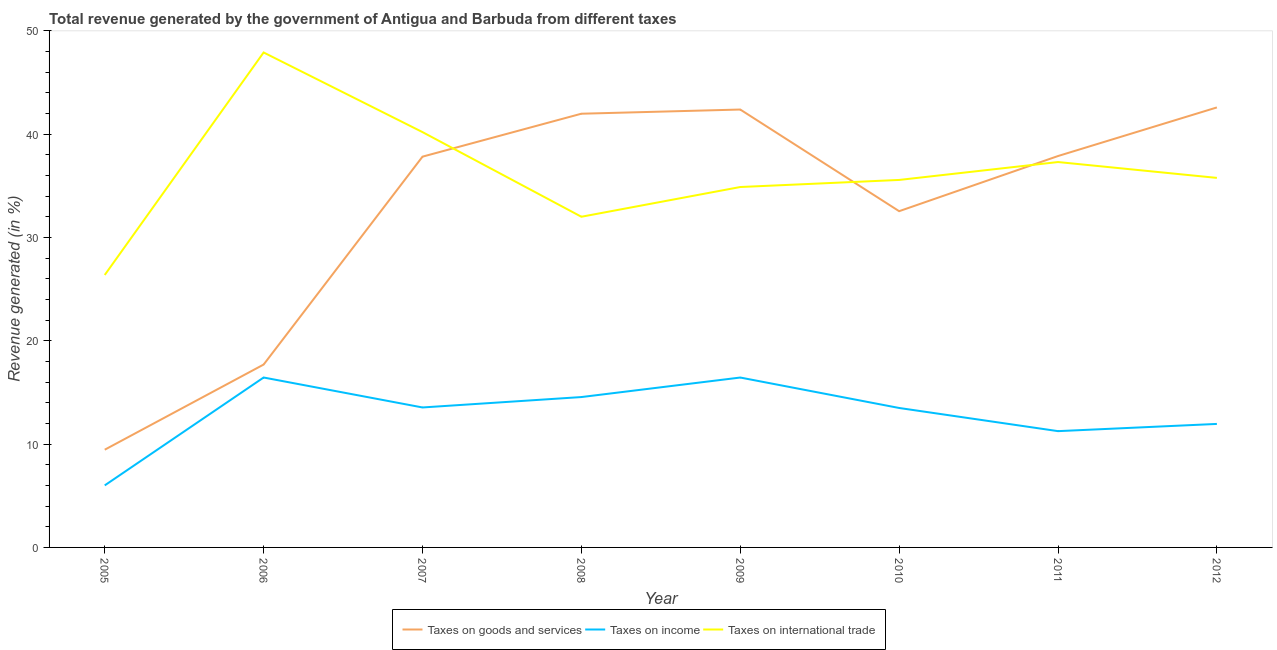Does the line corresponding to percentage of revenue generated by taxes on goods and services intersect with the line corresponding to percentage of revenue generated by taxes on income?
Offer a terse response. No. Is the number of lines equal to the number of legend labels?
Give a very brief answer. Yes. What is the percentage of revenue generated by taxes on goods and services in 2006?
Make the answer very short. 17.7. Across all years, what is the maximum percentage of revenue generated by taxes on goods and services?
Make the answer very short. 42.59. Across all years, what is the minimum percentage of revenue generated by tax on international trade?
Your answer should be very brief. 26.37. What is the total percentage of revenue generated by tax on international trade in the graph?
Give a very brief answer. 290.04. What is the difference between the percentage of revenue generated by tax on international trade in 2006 and that in 2009?
Your response must be concise. 13.02. What is the difference between the percentage of revenue generated by taxes on income in 2011 and the percentage of revenue generated by tax on international trade in 2005?
Your answer should be very brief. -15.12. What is the average percentage of revenue generated by tax on international trade per year?
Offer a very short reply. 36.26. In the year 2009, what is the difference between the percentage of revenue generated by taxes on goods and services and percentage of revenue generated by tax on international trade?
Provide a short and direct response. 7.5. What is the ratio of the percentage of revenue generated by taxes on income in 2005 to that in 2006?
Offer a terse response. 0.37. Is the difference between the percentage of revenue generated by tax on international trade in 2005 and 2006 greater than the difference between the percentage of revenue generated by taxes on income in 2005 and 2006?
Your answer should be very brief. No. What is the difference between the highest and the second highest percentage of revenue generated by taxes on goods and services?
Provide a short and direct response. 0.2. What is the difference between the highest and the lowest percentage of revenue generated by taxes on income?
Give a very brief answer. 10.44. Is the sum of the percentage of revenue generated by taxes on income in 2006 and 2011 greater than the maximum percentage of revenue generated by tax on international trade across all years?
Offer a terse response. No. Is the percentage of revenue generated by taxes on goods and services strictly less than the percentage of revenue generated by taxes on income over the years?
Make the answer very short. No. How many lines are there?
Your answer should be very brief. 3. What is the difference between two consecutive major ticks on the Y-axis?
Your answer should be compact. 10. Does the graph contain any zero values?
Offer a terse response. No. Does the graph contain grids?
Make the answer very short. No. How many legend labels are there?
Provide a short and direct response. 3. How are the legend labels stacked?
Your answer should be very brief. Horizontal. What is the title of the graph?
Your answer should be compact. Total revenue generated by the government of Antigua and Barbuda from different taxes. Does "Ireland" appear as one of the legend labels in the graph?
Keep it short and to the point. No. What is the label or title of the Y-axis?
Your answer should be compact. Revenue generated (in %). What is the Revenue generated (in %) of Taxes on goods and services in 2005?
Your response must be concise. 9.46. What is the Revenue generated (in %) in Taxes on income in 2005?
Provide a short and direct response. 6.01. What is the Revenue generated (in %) of Taxes on international trade in 2005?
Your answer should be compact. 26.37. What is the Revenue generated (in %) in Taxes on goods and services in 2006?
Your response must be concise. 17.7. What is the Revenue generated (in %) of Taxes on income in 2006?
Provide a succinct answer. 16.45. What is the Revenue generated (in %) in Taxes on international trade in 2006?
Your answer should be compact. 47.91. What is the Revenue generated (in %) in Taxes on goods and services in 2007?
Offer a terse response. 37.83. What is the Revenue generated (in %) in Taxes on income in 2007?
Provide a succinct answer. 13.55. What is the Revenue generated (in %) in Taxes on international trade in 2007?
Your answer should be compact. 40.2. What is the Revenue generated (in %) of Taxes on goods and services in 2008?
Make the answer very short. 41.98. What is the Revenue generated (in %) of Taxes on income in 2008?
Provide a succinct answer. 14.56. What is the Revenue generated (in %) in Taxes on international trade in 2008?
Make the answer very short. 32.01. What is the Revenue generated (in %) of Taxes on goods and services in 2009?
Keep it short and to the point. 42.39. What is the Revenue generated (in %) of Taxes on income in 2009?
Your response must be concise. 16.45. What is the Revenue generated (in %) of Taxes on international trade in 2009?
Provide a succinct answer. 34.89. What is the Revenue generated (in %) in Taxes on goods and services in 2010?
Your answer should be very brief. 32.55. What is the Revenue generated (in %) in Taxes on income in 2010?
Provide a succinct answer. 13.5. What is the Revenue generated (in %) of Taxes on international trade in 2010?
Ensure brevity in your answer.  35.57. What is the Revenue generated (in %) of Taxes on goods and services in 2011?
Offer a very short reply. 37.89. What is the Revenue generated (in %) in Taxes on income in 2011?
Offer a terse response. 11.26. What is the Revenue generated (in %) in Taxes on international trade in 2011?
Keep it short and to the point. 37.31. What is the Revenue generated (in %) of Taxes on goods and services in 2012?
Give a very brief answer. 42.59. What is the Revenue generated (in %) of Taxes on income in 2012?
Provide a succinct answer. 11.95. What is the Revenue generated (in %) of Taxes on international trade in 2012?
Your answer should be compact. 35.77. Across all years, what is the maximum Revenue generated (in %) of Taxes on goods and services?
Offer a very short reply. 42.59. Across all years, what is the maximum Revenue generated (in %) of Taxes on income?
Offer a very short reply. 16.45. Across all years, what is the maximum Revenue generated (in %) in Taxes on international trade?
Make the answer very short. 47.91. Across all years, what is the minimum Revenue generated (in %) of Taxes on goods and services?
Make the answer very short. 9.46. Across all years, what is the minimum Revenue generated (in %) in Taxes on income?
Your answer should be compact. 6.01. Across all years, what is the minimum Revenue generated (in %) of Taxes on international trade?
Provide a succinct answer. 26.37. What is the total Revenue generated (in %) in Taxes on goods and services in the graph?
Provide a succinct answer. 262.39. What is the total Revenue generated (in %) of Taxes on income in the graph?
Provide a succinct answer. 103.71. What is the total Revenue generated (in %) of Taxes on international trade in the graph?
Your response must be concise. 290.04. What is the difference between the Revenue generated (in %) in Taxes on goods and services in 2005 and that in 2006?
Provide a succinct answer. -8.24. What is the difference between the Revenue generated (in %) in Taxes on income in 2005 and that in 2006?
Give a very brief answer. -10.44. What is the difference between the Revenue generated (in %) in Taxes on international trade in 2005 and that in 2006?
Ensure brevity in your answer.  -21.54. What is the difference between the Revenue generated (in %) of Taxes on goods and services in 2005 and that in 2007?
Provide a short and direct response. -28.37. What is the difference between the Revenue generated (in %) in Taxes on income in 2005 and that in 2007?
Your answer should be compact. -7.54. What is the difference between the Revenue generated (in %) of Taxes on international trade in 2005 and that in 2007?
Give a very brief answer. -13.83. What is the difference between the Revenue generated (in %) in Taxes on goods and services in 2005 and that in 2008?
Provide a succinct answer. -32.52. What is the difference between the Revenue generated (in %) in Taxes on income in 2005 and that in 2008?
Provide a short and direct response. -8.55. What is the difference between the Revenue generated (in %) in Taxes on international trade in 2005 and that in 2008?
Your response must be concise. -5.64. What is the difference between the Revenue generated (in %) of Taxes on goods and services in 2005 and that in 2009?
Ensure brevity in your answer.  -32.93. What is the difference between the Revenue generated (in %) in Taxes on income in 2005 and that in 2009?
Provide a short and direct response. -10.44. What is the difference between the Revenue generated (in %) of Taxes on international trade in 2005 and that in 2009?
Keep it short and to the point. -8.51. What is the difference between the Revenue generated (in %) in Taxes on goods and services in 2005 and that in 2010?
Offer a very short reply. -23.09. What is the difference between the Revenue generated (in %) of Taxes on income in 2005 and that in 2010?
Your answer should be compact. -7.49. What is the difference between the Revenue generated (in %) in Taxes on international trade in 2005 and that in 2010?
Give a very brief answer. -9.2. What is the difference between the Revenue generated (in %) in Taxes on goods and services in 2005 and that in 2011?
Your response must be concise. -28.43. What is the difference between the Revenue generated (in %) of Taxes on income in 2005 and that in 2011?
Offer a terse response. -5.25. What is the difference between the Revenue generated (in %) of Taxes on international trade in 2005 and that in 2011?
Make the answer very short. -10.93. What is the difference between the Revenue generated (in %) in Taxes on goods and services in 2005 and that in 2012?
Your answer should be very brief. -33.13. What is the difference between the Revenue generated (in %) in Taxes on income in 2005 and that in 2012?
Your response must be concise. -5.95. What is the difference between the Revenue generated (in %) of Taxes on international trade in 2005 and that in 2012?
Provide a succinct answer. -9.4. What is the difference between the Revenue generated (in %) of Taxes on goods and services in 2006 and that in 2007?
Make the answer very short. -20.13. What is the difference between the Revenue generated (in %) in Taxes on income in 2006 and that in 2007?
Ensure brevity in your answer.  2.9. What is the difference between the Revenue generated (in %) of Taxes on international trade in 2006 and that in 2007?
Your response must be concise. 7.71. What is the difference between the Revenue generated (in %) in Taxes on goods and services in 2006 and that in 2008?
Your response must be concise. -24.28. What is the difference between the Revenue generated (in %) of Taxes on income in 2006 and that in 2008?
Keep it short and to the point. 1.89. What is the difference between the Revenue generated (in %) of Taxes on international trade in 2006 and that in 2008?
Give a very brief answer. 15.9. What is the difference between the Revenue generated (in %) in Taxes on goods and services in 2006 and that in 2009?
Offer a terse response. -24.69. What is the difference between the Revenue generated (in %) in Taxes on income in 2006 and that in 2009?
Provide a succinct answer. 0. What is the difference between the Revenue generated (in %) of Taxes on international trade in 2006 and that in 2009?
Give a very brief answer. 13.02. What is the difference between the Revenue generated (in %) of Taxes on goods and services in 2006 and that in 2010?
Provide a short and direct response. -14.85. What is the difference between the Revenue generated (in %) in Taxes on income in 2006 and that in 2010?
Ensure brevity in your answer.  2.95. What is the difference between the Revenue generated (in %) in Taxes on international trade in 2006 and that in 2010?
Offer a terse response. 12.34. What is the difference between the Revenue generated (in %) in Taxes on goods and services in 2006 and that in 2011?
Your response must be concise. -20.19. What is the difference between the Revenue generated (in %) in Taxes on income in 2006 and that in 2011?
Your answer should be very brief. 5.19. What is the difference between the Revenue generated (in %) of Taxes on international trade in 2006 and that in 2011?
Offer a very short reply. 10.61. What is the difference between the Revenue generated (in %) of Taxes on goods and services in 2006 and that in 2012?
Ensure brevity in your answer.  -24.89. What is the difference between the Revenue generated (in %) in Taxes on income in 2006 and that in 2012?
Provide a short and direct response. 4.49. What is the difference between the Revenue generated (in %) in Taxes on international trade in 2006 and that in 2012?
Provide a short and direct response. 12.14. What is the difference between the Revenue generated (in %) in Taxes on goods and services in 2007 and that in 2008?
Your answer should be compact. -4.16. What is the difference between the Revenue generated (in %) in Taxes on income in 2007 and that in 2008?
Provide a succinct answer. -1.01. What is the difference between the Revenue generated (in %) in Taxes on international trade in 2007 and that in 2008?
Give a very brief answer. 8.19. What is the difference between the Revenue generated (in %) of Taxes on goods and services in 2007 and that in 2009?
Ensure brevity in your answer.  -4.56. What is the difference between the Revenue generated (in %) in Taxes on income in 2007 and that in 2009?
Ensure brevity in your answer.  -2.9. What is the difference between the Revenue generated (in %) in Taxes on international trade in 2007 and that in 2009?
Your response must be concise. 5.32. What is the difference between the Revenue generated (in %) in Taxes on goods and services in 2007 and that in 2010?
Ensure brevity in your answer.  5.28. What is the difference between the Revenue generated (in %) in Taxes on income in 2007 and that in 2010?
Ensure brevity in your answer.  0.05. What is the difference between the Revenue generated (in %) in Taxes on international trade in 2007 and that in 2010?
Keep it short and to the point. 4.63. What is the difference between the Revenue generated (in %) of Taxes on goods and services in 2007 and that in 2011?
Offer a terse response. -0.06. What is the difference between the Revenue generated (in %) of Taxes on income in 2007 and that in 2011?
Make the answer very short. 2.29. What is the difference between the Revenue generated (in %) of Taxes on international trade in 2007 and that in 2011?
Your answer should be compact. 2.9. What is the difference between the Revenue generated (in %) in Taxes on goods and services in 2007 and that in 2012?
Provide a short and direct response. -4.76. What is the difference between the Revenue generated (in %) in Taxes on income in 2007 and that in 2012?
Provide a short and direct response. 1.59. What is the difference between the Revenue generated (in %) of Taxes on international trade in 2007 and that in 2012?
Your response must be concise. 4.43. What is the difference between the Revenue generated (in %) of Taxes on goods and services in 2008 and that in 2009?
Provide a short and direct response. -0.41. What is the difference between the Revenue generated (in %) of Taxes on income in 2008 and that in 2009?
Your response must be concise. -1.89. What is the difference between the Revenue generated (in %) in Taxes on international trade in 2008 and that in 2009?
Keep it short and to the point. -2.88. What is the difference between the Revenue generated (in %) of Taxes on goods and services in 2008 and that in 2010?
Offer a very short reply. 9.44. What is the difference between the Revenue generated (in %) in Taxes on income in 2008 and that in 2010?
Keep it short and to the point. 1.06. What is the difference between the Revenue generated (in %) of Taxes on international trade in 2008 and that in 2010?
Make the answer very short. -3.56. What is the difference between the Revenue generated (in %) in Taxes on goods and services in 2008 and that in 2011?
Provide a succinct answer. 4.1. What is the difference between the Revenue generated (in %) in Taxes on income in 2008 and that in 2011?
Give a very brief answer. 3.3. What is the difference between the Revenue generated (in %) in Taxes on international trade in 2008 and that in 2011?
Make the answer very short. -5.3. What is the difference between the Revenue generated (in %) of Taxes on goods and services in 2008 and that in 2012?
Your response must be concise. -0.61. What is the difference between the Revenue generated (in %) in Taxes on income in 2008 and that in 2012?
Give a very brief answer. 2.6. What is the difference between the Revenue generated (in %) in Taxes on international trade in 2008 and that in 2012?
Make the answer very short. -3.76. What is the difference between the Revenue generated (in %) in Taxes on goods and services in 2009 and that in 2010?
Your response must be concise. 9.84. What is the difference between the Revenue generated (in %) in Taxes on income in 2009 and that in 2010?
Offer a very short reply. 2.95. What is the difference between the Revenue generated (in %) in Taxes on international trade in 2009 and that in 2010?
Your answer should be compact. -0.69. What is the difference between the Revenue generated (in %) of Taxes on goods and services in 2009 and that in 2011?
Make the answer very short. 4.5. What is the difference between the Revenue generated (in %) in Taxes on income in 2009 and that in 2011?
Your response must be concise. 5.19. What is the difference between the Revenue generated (in %) of Taxes on international trade in 2009 and that in 2011?
Offer a terse response. -2.42. What is the difference between the Revenue generated (in %) in Taxes on goods and services in 2009 and that in 2012?
Provide a succinct answer. -0.2. What is the difference between the Revenue generated (in %) in Taxes on income in 2009 and that in 2012?
Ensure brevity in your answer.  4.49. What is the difference between the Revenue generated (in %) in Taxes on international trade in 2009 and that in 2012?
Your answer should be compact. -0.88. What is the difference between the Revenue generated (in %) in Taxes on goods and services in 2010 and that in 2011?
Provide a short and direct response. -5.34. What is the difference between the Revenue generated (in %) of Taxes on income in 2010 and that in 2011?
Ensure brevity in your answer.  2.24. What is the difference between the Revenue generated (in %) of Taxes on international trade in 2010 and that in 2011?
Offer a very short reply. -1.73. What is the difference between the Revenue generated (in %) of Taxes on goods and services in 2010 and that in 2012?
Your response must be concise. -10.04. What is the difference between the Revenue generated (in %) of Taxes on income in 2010 and that in 2012?
Provide a short and direct response. 1.54. What is the difference between the Revenue generated (in %) of Taxes on international trade in 2010 and that in 2012?
Provide a short and direct response. -0.2. What is the difference between the Revenue generated (in %) of Taxes on goods and services in 2011 and that in 2012?
Your answer should be compact. -4.7. What is the difference between the Revenue generated (in %) of Taxes on income in 2011 and that in 2012?
Your response must be concise. -0.7. What is the difference between the Revenue generated (in %) in Taxes on international trade in 2011 and that in 2012?
Ensure brevity in your answer.  1.53. What is the difference between the Revenue generated (in %) of Taxes on goods and services in 2005 and the Revenue generated (in %) of Taxes on income in 2006?
Your answer should be compact. -6.99. What is the difference between the Revenue generated (in %) of Taxes on goods and services in 2005 and the Revenue generated (in %) of Taxes on international trade in 2006?
Provide a succinct answer. -38.45. What is the difference between the Revenue generated (in %) of Taxes on income in 2005 and the Revenue generated (in %) of Taxes on international trade in 2006?
Offer a terse response. -41.91. What is the difference between the Revenue generated (in %) of Taxes on goods and services in 2005 and the Revenue generated (in %) of Taxes on income in 2007?
Your answer should be very brief. -4.09. What is the difference between the Revenue generated (in %) of Taxes on goods and services in 2005 and the Revenue generated (in %) of Taxes on international trade in 2007?
Provide a short and direct response. -30.74. What is the difference between the Revenue generated (in %) of Taxes on income in 2005 and the Revenue generated (in %) of Taxes on international trade in 2007?
Keep it short and to the point. -34.2. What is the difference between the Revenue generated (in %) in Taxes on goods and services in 2005 and the Revenue generated (in %) in Taxes on income in 2008?
Offer a terse response. -5.1. What is the difference between the Revenue generated (in %) of Taxes on goods and services in 2005 and the Revenue generated (in %) of Taxes on international trade in 2008?
Your answer should be very brief. -22.55. What is the difference between the Revenue generated (in %) of Taxes on income in 2005 and the Revenue generated (in %) of Taxes on international trade in 2008?
Your answer should be very brief. -26.01. What is the difference between the Revenue generated (in %) of Taxes on goods and services in 2005 and the Revenue generated (in %) of Taxes on income in 2009?
Provide a short and direct response. -6.99. What is the difference between the Revenue generated (in %) of Taxes on goods and services in 2005 and the Revenue generated (in %) of Taxes on international trade in 2009?
Your answer should be compact. -25.43. What is the difference between the Revenue generated (in %) of Taxes on income in 2005 and the Revenue generated (in %) of Taxes on international trade in 2009?
Make the answer very short. -28.88. What is the difference between the Revenue generated (in %) in Taxes on goods and services in 2005 and the Revenue generated (in %) in Taxes on income in 2010?
Offer a very short reply. -4.04. What is the difference between the Revenue generated (in %) in Taxes on goods and services in 2005 and the Revenue generated (in %) in Taxes on international trade in 2010?
Your response must be concise. -26.11. What is the difference between the Revenue generated (in %) of Taxes on income in 2005 and the Revenue generated (in %) of Taxes on international trade in 2010?
Your answer should be compact. -29.57. What is the difference between the Revenue generated (in %) of Taxes on goods and services in 2005 and the Revenue generated (in %) of Taxes on income in 2011?
Your response must be concise. -1.8. What is the difference between the Revenue generated (in %) in Taxes on goods and services in 2005 and the Revenue generated (in %) in Taxes on international trade in 2011?
Your answer should be compact. -27.85. What is the difference between the Revenue generated (in %) in Taxes on income in 2005 and the Revenue generated (in %) in Taxes on international trade in 2011?
Make the answer very short. -31.3. What is the difference between the Revenue generated (in %) in Taxes on goods and services in 2005 and the Revenue generated (in %) in Taxes on income in 2012?
Your answer should be very brief. -2.5. What is the difference between the Revenue generated (in %) in Taxes on goods and services in 2005 and the Revenue generated (in %) in Taxes on international trade in 2012?
Your answer should be very brief. -26.31. What is the difference between the Revenue generated (in %) of Taxes on income in 2005 and the Revenue generated (in %) of Taxes on international trade in 2012?
Give a very brief answer. -29.77. What is the difference between the Revenue generated (in %) of Taxes on goods and services in 2006 and the Revenue generated (in %) of Taxes on income in 2007?
Give a very brief answer. 4.15. What is the difference between the Revenue generated (in %) of Taxes on goods and services in 2006 and the Revenue generated (in %) of Taxes on international trade in 2007?
Make the answer very short. -22.5. What is the difference between the Revenue generated (in %) in Taxes on income in 2006 and the Revenue generated (in %) in Taxes on international trade in 2007?
Offer a very short reply. -23.76. What is the difference between the Revenue generated (in %) in Taxes on goods and services in 2006 and the Revenue generated (in %) in Taxes on income in 2008?
Make the answer very short. 3.15. What is the difference between the Revenue generated (in %) of Taxes on goods and services in 2006 and the Revenue generated (in %) of Taxes on international trade in 2008?
Give a very brief answer. -14.31. What is the difference between the Revenue generated (in %) in Taxes on income in 2006 and the Revenue generated (in %) in Taxes on international trade in 2008?
Your response must be concise. -15.56. What is the difference between the Revenue generated (in %) in Taxes on goods and services in 2006 and the Revenue generated (in %) in Taxes on income in 2009?
Offer a very short reply. 1.26. What is the difference between the Revenue generated (in %) in Taxes on goods and services in 2006 and the Revenue generated (in %) in Taxes on international trade in 2009?
Offer a terse response. -17.19. What is the difference between the Revenue generated (in %) in Taxes on income in 2006 and the Revenue generated (in %) in Taxes on international trade in 2009?
Ensure brevity in your answer.  -18.44. What is the difference between the Revenue generated (in %) in Taxes on goods and services in 2006 and the Revenue generated (in %) in Taxes on income in 2010?
Ensure brevity in your answer.  4.2. What is the difference between the Revenue generated (in %) in Taxes on goods and services in 2006 and the Revenue generated (in %) in Taxes on international trade in 2010?
Ensure brevity in your answer.  -17.87. What is the difference between the Revenue generated (in %) in Taxes on income in 2006 and the Revenue generated (in %) in Taxes on international trade in 2010?
Your answer should be compact. -19.13. What is the difference between the Revenue generated (in %) of Taxes on goods and services in 2006 and the Revenue generated (in %) of Taxes on income in 2011?
Your answer should be very brief. 6.45. What is the difference between the Revenue generated (in %) of Taxes on goods and services in 2006 and the Revenue generated (in %) of Taxes on international trade in 2011?
Offer a very short reply. -19.6. What is the difference between the Revenue generated (in %) of Taxes on income in 2006 and the Revenue generated (in %) of Taxes on international trade in 2011?
Offer a terse response. -20.86. What is the difference between the Revenue generated (in %) of Taxes on goods and services in 2006 and the Revenue generated (in %) of Taxes on income in 2012?
Provide a succinct answer. 5.75. What is the difference between the Revenue generated (in %) in Taxes on goods and services in 2006 and the Revenue generated (in %) in Taxes on international trade in 2012?
Your answer should be very brief. -18.07. What is the difference between the Revenue generated (in %) of Taxes on income in 2006 and the Revenue generated (in %) of Taxes on international trade in 2012?
Offer a terse response. -19.32. What is the difference between the Revenue generated (in %) of Taxes on goods and services in 2007 and the Revenue generated (in %) of Taxes on income in 2008?
Your response must be concise. 23.27. What is the difference between the Revenue generated (in %) of Taxes on goods and services in 2007 and the Revenue generated (in %) of Taxes on international trade in 2008?
Offer a very short reply. 5.82. What is the difference between the Revenue generated (in %) of Taxes on income in 2007 and the Revenue generated (in %) of Taxes on international trade in 2008?
Provide a short and direct response. -18.46. What is the difference between the Revenue generated (in %) in Taxes on goods and services in 2007 and the Revenue generated (in %) in Taxes on income in 2009?
Your answer should be very brief. 21.38. What is the difference between the Revenue generated (in %) of Taxes on goods and services in 2007 and the Revenue generated (in %) of Taxes on international trade in 2009?
Provide a short and direct response. 2.94. What is the difference between the Revenue generated (in %) of Taxes on income in 2007 and the Revenue generated (in %) of Taxes on international trade in 2009?
Your response must be concise. -21.34. What is the difference between the Revenue generated (in %) of Taxes on goods and services in 2007 and the Revenue generated (in %) of Taxes on income in 2010?
Provide a short and direct response. 24.33. What is the difference between the Revenue generated (in %) in Taxes on goods and services in 2007 and the Revenue generated (in %) in Taxes on international trade in 2010?
Offer a very short reply. 2.25. What is the difference between the Revenue generated (in %) in Taxes on income in 2007 and the Revenue generated (in %) in Taxes on international trade in 2010?
Make the answer very short. -22.02. What is the difference between the Revenue generated (in %) of Taxes on goods and services in 2007 and the Revenue generated (in %) of Taxes on income in 2011?
Provide a short and direct response. 26.57. What is the difference between the Revenue generated (in %) of Taxes on goods and services in 2007 and the Revenue generated (in %) of Taxes on international trade in 2011?
Your response must be concise. 0.52. What is the difference between the Revenue generated (in %) of Taxes on income in 2007 and the Revenue generated (in %) of Taxes on international trade in 2011?
Offer a terse response. -23.76. What is the difference between the Revenue generated (in %) of Taxes on goods and services in 2007 and the Revenue generated (in %) of Taxes on income in 2012?
Keep it short and to the point. 25.87. What is the difference between the Revenue generated (in %) of Taxes on goods and services in 2007 and the Revenue generated (in %) of Taxes on international trade in 2012?
Your answer should be very brief. 2.06. What is the difference between the Revenue generated (in %) in Taxes on income in 2007 and the Revenue generated (in %) in Taxes on international trade in 2012?
Your answer should be very brief. -22.22. What is the difference between the Revenue generated (in %) in Taxes on goods and services in 2008 and the Revenue generated (in %) in Taxes on income in 2009?
Provide a succinct answer. 25.54. What is the difference between the Revenue generated (in %) of Taxes on goods and services in 2008 and the Revenue generated (in %) of Taxes on international trade in 2009?
Offer a very short reply. 7.1. What is the difference between the Revenue generated (in %) in Taxes on income in 2008 and the Revenue generated (in %) in Taxes on international trade in 2009?
Your answer should be compact. -20.33. What is the difference between the Revenue generated (in %) of Taxes on goods and services in 2008 and the Revenue generated (in %) of Taxes on income in 2010?
Give a very brief answer. 28.49. What is the difference between the Revenue generated (in %) of Taxes on goods and services in 2008 and the Revenue generated (in %) of Taxes on international trade in 2010?
Your response must be concise. 6.41. What is the difference between the Revenue generated (in %) of Taxes on income in 2008 and the Revenue generated (in %) of Taxes on international trade in 2010?
Give a very brief answer. -21.02. What is the difference between the Revenue generated (in %) of Taxes on goods and services in 2008 and the Revenue generated (in %) of Taxes on income in 2011?
Make the answer very short. 30.73. What is the difference between the Revenue generated (in %) in Taxes on goods and services in 2008 and the Revenue generated (in %) in Taxes on international trade in 2011?
Offer a terse response. 4.68. What is the difference between the Revenue generated (in %) in Taxes on income in 2008 and the Revenue generated (in %) in Taxes on international trade in 2011?
Keep it short and to the point. -22.75. What is the difference between the Revenue generated (in %) in Taxes on goods and services in 2008 and the Revenue generated (in %) in Taxes on income in 2012?
Provide a succinct answer. 30.03. What is the difference between the Revenue generated (in %) of Taxes on goods and services in 2008 and the Revenue generated (in %) of Taxes on international trade in 2012?
Give a very brief answer. 6.21. What is the difference between the Revenue generated (in %) of Taxes on income in 2008 and the Revenue generated (in %) of Taxes on international trade in 2012?
Give a very brief answer. -21.22. What is the difference between the Revenue generated (in %) in Taxes on goods and services in 2009 and the Revenue generated (in %) in Taxes on income in 2010?
Your response must be concise. 28.89. What is the difference between the Revenue generated (in %) in Taxes on goods and services in 2009 and the Revenue generated (in %) in Taxes on international trade in 2010?
Make the answer very short. 6.82. What is the difference between the Revenue generated (in %) of Taxes on income in 2009 and the Revenue generated (in %) of Taxes on international trade in 2010?
Offer a very short reply. -19.13. What is the difference between the Revenue generated (in %) in Taxes on goods and services in 2009 and the Revenue generated (in %) in Taxes on income in 2011?
Provide a succinct answer. 31.13. What is the difference between the Revenue generated (in %) of Taxes on goods and services in 2009 and the Revenue generated (in %) of Taxes on international trade in 2011?
Make the answer very short. 5.08. What is the difference between the Revenue generated (in %) in Taxes on income in 2009 and the Revenue generated (in %) in Taxes on international trade in 2011?
Provide a short and direct response. -20.86. What is the difference between the Revenue generated (in %) of Taxes on goods and services in 2009 and the Revenue generated (in %) of Taxes on income in 2012?
Make the answer very short. 30.43. What is the difference between the Revenue generated (in %) in Taxes on goods and services in 2009 and the Revenue generated (in %) in Taxes on international trade in 2012?
Make the answer very short. 6.62. What is the difference between the Revenue generated (in %) in Taxes on income in 2009 and the Revenue generated (in %) in Taxes on international trade in 2012?
Give a very brief answer. -19.33. What is the difference between the Revenue generated (in %) of Taxes on goods and services in 2010 and the Revenue generated (in %) of Taxes on income in 2011?
Your answer should be very brief. 21.29. What is the difference between the Revenue generated (in %) in Taxes on goods and services in 2010 and the Revenue generated (in %) in Taxes on international trade in 2011?
Your answer should be very brief. -4.76. What is the difference between the Revenue generated (in %) of Taxes on income in 2010 and the Revenue generated (in %) of Taxes on international trade in 2011?
Offer a very short reply. -23.81. What is the difference between the Revenue generated (in %) of Taxes on goods and services in 2010 and the Revenue generated (in %) of Taxes on income in 2012?
Offer a terse response. 20.59. What is the difference between the Revenue generated (in %) of Taxes on goods and services in 2010 and the Revenue generated (in %) of Taxes on international trade in 2012?
Provide a succinct answer. -3.22. What is the difference between the Revenue generated (in %) of Taxes on income in 2010 and the Revenue generated (in %) of Taxes on international trade in 2012?
Offer a very short reply. -22.27. What is the difference between the Revenue generated (in %) in Taxes on goods and services in 2011 and the Revenue generated (in %) in Taxes on income in 2012?
Your answer should be compact. 25.93. What is the difference between the Revenue generated (in %) in Taxes on goods and services in 2011 and the Revenue generated (in %) in Taxes on international trade in 2012?
Keep it short and to the point. 2.12. What is the difference between the Revenue generated (in %) in Taxes on income in 2011 and the Revenue generated (in %) in Taxes on international trade in 2012?
Offer a terse response. -24.52. What is the average Revenue generated (in %) in Taxes on goods and services per year?
Your response must be concise. 32.8. What is the average Revenue generated (in %) of Taxes on income per year?
Your answer should be very brief. 12.96. What is the average Revenue generated (in %) in Taxes on international trade per year?
Provide a succinct answer. 36.26. In the year 2005, what is the difference between the Revenue generated (in %) in Taxes on goods and services and Revenue generated (in %) in Taxes on income?
Provide a short and direct response. 3.45. In the year 2005, what is the difference between the Revenue generated (in %) in Taxes on goods and services and Revenue generated (in %) in Taxes on international trade?
Offer a terse response. -16.91. In the year 2005, what is the difference between the Revenue generated (in %) in Taxes on income and Revenue generated (in %) in Taxes on international trade?
Offer a terse response. -20.37. In the year 2006, what is the difference between the Revenue generated (in %) of Taxes on goods and services and Revenue generated (in %) of Taxes on income?
Offer a very short reply. 1.25. In the year 2006, what is the difference between the Revenue generated (in %) in Taxes on goods and services and Revenue generated (in %) in Taxes on international trade?
Keep it short and to the point. -30.21. In the year 2006, what is the difference between the Revenue generated (in %) in Taxes on income and Revenue generated (in %) in Taxes on international trade?
Keep it short and to the point. -31.46. In the year 2007, what is the difference between the Revenue generated (in %) in Taxes on goods and services and Revenue generated (in %) in Taxes on income?
Provide a succinct answer. 24.28. In the year 2007, what is the difference between the Revenue generated (in %) of Taxes on goods and services and Revenue generated (in %) of Taxes on international trade?
Your answer should be compact. -2.38. In the year 2007, what is the difference between the Revenue generated (in %) of Taxes on income and Revenue generated (in %) of Taxes on international trade?
Provide a short and direct response. -26.66. In the year 2008, what is the difference between the Revenue generated (in %) in Taxes on goods and services and Revenue generated (in %) in Taxes on income?
Your answer should be very brief. 27.43. In the year 2008, what is the difference between the Revenue generated (in %) in Taxes on goods and services and Revenue generated (in %) in Taxes on international trade?
Make the answer very short. 9.97. In the year 2008, what is the difference between the Revenue generated (in %) in Taxes on income and Revenue generated (in %) in Taxes on international trade?
Offer a terse response. -17.45. In the year 2009, what is the difference between the Revenue generated (in %) in Taxes on goods and services and Revenue generated (in %) in Taxes on income?
Ensure brevity in your answer.  25.94. In the year 2009, what is the difference between the Revenue generated (in %) in Taxes on goods and services and Revenue generated (in %) in Taxes on international trade?
Offer a very short reply. 7.5. In the year 2009, what is the difference between the Revenue generated (in %) in Taxes on income and Revenue generated (in %) in Taxes on international trade?
Your response must be concise. -18.44. In the year 2010, what is the difference between the Revenue generated (in %) in Taxes on goods and services and Revenue generated (in %) in Taxes on income?
Your answer should be compact. 19.05. In the year 2010, what is the difference between the Revenue generated (in %) of Taxes on goods and services and Revenue generated (in %) of Taxes on international trade?
Provide a succinct answer. -3.02. In the year 2010, what is the difference between the Revenue generated (in %) in Taxes on income and Revenue generated (in %) in Taxes on international trade?
Keep it short and to the point. -22.07. In the year 2011, what is the difference between the Revenue generated (in %) in Taxes on goods and services and Revenue generated (in %) in Taxes on income?
Provide a succinct answer. 26.63. In the year 2011, what is the difference between the Revenue generated (in %) of Taxes on goods and services and Revenue generated (in %) of Taxes on international trade?
Make the answer very short. 0.58. In the year 2011, what is the difference between the Revenue generated (in %) of Taxes on income and Revenue generated (in %) of Taxes on international trade?
Your response must be concise. -26.05. In the year 2012, what is the difference between the Revenue generated (in %) of Taxes on goods and services and Revenue generated (in %) of Taxes on income?
Make the answer very short. 30.64. In the year 2012, what is the difference between the Revenue generated (in %) in Taxes on goods and services and Revenue generated (in %) in Taxes on international trade?
Your answer should be compact. 6.82. In the year 2012, what is the difference between the Revenue generated (in %) in Taxes on income and Revenue generated (in %) in Taxes on international trade?
Offer a terse response. -23.82. What is the ratio of the Revenue generated (in %) in Taxes on goods and services in 2005 to that in 2006?
Offer a very short reply. 0.53. What is the ratio of the Revenue generated (in %) in Taxes on income in 2005 to that in 2006?
Make the answer very short. 0.37. What is the ratio of the Revenue generated (in %) of Taxes on international trade in 2005 to that in 2006?
Offer a very short reply. 0.55. What is the ratio of the Revenue generated (in %) in Taxes on goods and services in 2005 to that in 2007?
Keep it short and to the point. 0.25. What is the ratio of the Revenue generated (in %) of Taxes on income in 2005 to that in 2007?
Your response must be concise. 0.44. What is the ratio of the Revenue generated (in %) of Taxes on international trade in 2005 to that in 2007?
Your answer should be very brief. 0.66. What is the ratio of the Revenue generated (in %) of Taxes on goods and services in 2005 to that in 2008?
Offer a very short reply. 0.23. What is the ratio of the Revenue generated (in %) of Taxes on income in 2005 to that in 2008?
Your answer should be compact. 0.41. What is the ratio of the Revenue generated (in %) in Taxes on international trade in 2005 to that in 2008?
Your answer should be very brief. 0.82. What is the ratio of the Revenue generated (in %) in Taxes on goods and services in 2005 to that in 2009?
Keep it short and to the point. 0.22. What is the ratio of the Revenue generated (in %) of Taxes on income in 2005 to that in 2009?
Keep it short and to the point. 0.37. What is the ratio of the Revenue generated (in %) in Taxes on international trade in 2005 to that in 2009?
Your answer should be compact. 0.76. What is the ratio of the Revenue generated (in %) of Taxes on goods and services in 2005 to that in 2010?
Offer a terse response. 0.29. What is the ratio of the Revenue generated (in %) in Taxes on income in 2005 to that in 2010?
Keep it short and to the point. 0.44. What is the ratio of the Revenue generated (in %) in Taxes on international trade in 2005 to that in 2010?
Your response must be concise. 0.74. What is the ratio of the Revenue generated (in %) in Taxes on goods and services in 2005 to that in 2011?
Your answer should be compact. 0.25. What is the ratio of the Revenue generated (in %) in Taxes on income in 2005 to that in 2011?
Keep it short and to the point. 0.53. What is the ratio of the Revenue generated (in %) in Taxes on international trade in 2005 to that in 2011?
Make the answer very short. 0.71. What is the ratio of the Revenue generated (in %) of Taxes on goods and services in 2005 to that in 2012?
Your answer should be very brief. 0.22. What is the ratio of the Revenue generated (in %) in Taxes on income in 2005 to that in 2012?
Ensure brevity in your answer.  0.5. What is the ratio of the Revenue generated (in %) in Taxes on international trade in 2005 to that in 2012?
Give a very brief answer. 0.74. What is the ratio of the Revenue generated (in %) in Taxes on goods and services in 2006 to that in 2007?
Your answer should be compact. 0.47. What is the ratio of the Revenue generated (in %) in Taxes on income in 2006 to that in 2007?
Your answer should be very brief. 1.21. What is the ratio of the Revenue generated (in %) of Taxes on international trade in 2006 to that in 2007?
Your answer should be very brief. 1.19. What is the ratio of the Revenue generated (in %) of Taxes on goods and services in 2006 to that in 2008?
Keep it short and to the point. 0.42. What is the ratio of the Revenue generated (in %) in Taxes on income in 2006 to that in 2008?
Offer a terse response. 1.13. What is the ratio of the Revenue generated (in %) of Taxes on international trade in 2006 to that in 2008?
Your answer should be compact. 1.5. What is the ratio of the Revenue generated (in %) of Taxes on goods and services in 2006 to that in 2009?
Your response must be concise. 0.42. What is the ratio of the Revenue generated (in %) in Taxes on international trade in 2006 to that in 2009?
Make the answer very short. 1.37. What is the ratio of the Revenue generated (in %) of Taxes on goods and services in 2006 to that in 2010?
Your response must be concise. 0.54. What is the ratio of the Revenue generated (in %) of Taxes on income in 2006 to that in 2010?
Offer a very short reply. 1.22. What is the ratio of the Revenue generated (in %) of Taxes on international trade in 2006 to that in 2010?
Offer a very short reply. 1.35. What is the ratio of the Revenue generated (in %) in Taxes on goods and services in 2006 to that in 2011?
Your answer should be very brief. 0.47. What is the ratio of the Revenue generated (in %) of Taxes on income in 2006 to that in 2011?
Your answer should be compact. 1.46. What is the ratio of the Revenue generated (in %) in Taxes on international trade in 2006 to that in 2011?
Ensure brevity in your answer.  1.28. What is the ratio of the Revenue generated (in %) in Taxes on goods and services in 2006 to that in 2012?
Ensure brevity in your answer.  0.42. What is the ratio of the Revenue generated (in %) in Taxes on income in 2006 to that in 2012?
Your response must be concise. 1.38. What is the ratio of the Revenue generated (in %) in Taxes on international trade in 2006 to that in 2012?
Your answer should be compact. 1.34. What is the ratio of the Revenue generated (in %) of Taxes on goods and services in 2007 to that in 2008?
Offer a terse response. 0.9. What is the ratio of the Revenue generated (in %) in Taxes on income in 2007 to that in 2008?
Ensure brevity in your answer.  0.93. What is the ratio of the Revenue generated (in %) in Taxes on international trade in 2007 to that in 2008?
Your response must be concise. 1.26. What is the ratio of the Revenue generated (in %) of Taxes on goods and services in 2007 to that in 2009?
Provide a succinct answer. 0.89. What is the ratio of the Revenue generated (in %) in Taxes on income in 2007 to that in 2009?
Give a very brief answer. 0.82. What is the ratio of the Revenue generated (in %) in Taxes on international trade in 2007 to that in 2009?
Your answer should be compact. 1.15. What is the ratio of the Revenue generated (in %) of Taxes on goods and services in 2007 to that in 2010?
Give a very brief answer. 1.16. What is the ratio of the Revenue generated (in %) in Taxes on income in 2007 to that in 2010?
Provide a short and direct response. 1. What is the ratio of the Revenue generated (in %) of Taxes on international trade in 2007 to that in 2010?
Ensure brevity in your answer.  1.13. What is the ratio of the Revenue generated (in %) of Taxes on goods and services in 2007 to that in 2011?
Make the answer very short. 1. What is the ratio of the Revenue generated (in %) of Taxes on income in 2007 to that in 2011?
Your answer should be very brief. 1.2. What is the ratio of the Revenue generated (in %) of Taxes on international trade in 2007 to that in 2011?
Offer a very short reply. 1.08. What is the ratio of the Revenue generated (in %) in Taxes on goods and services in 2007 to that in 2012?
Offer a terse response. 0.89. What is the ratio of the Revenue generated (in %) of Taxes on income in 2007 to that in 2012?
Provide a succinct answer. 1.13. What is the ratio of the Revenue generated (in %) of Taxes on international trade in 2007 to that in 2012?
Give a very brief answer. 1.12. What is the ratio of the Revenue generated (in %) in Taxes on income in 2008 to that in 2009?
Keep it short and to the point. 0.89. What is the ratio of the Revenue generated (in %) in Taxes on international trade in 2008 to that in 2009?
Offer a very short reply. 0.92. What is the ratio of the Revenue generated (in %) of Taxes on goods and services in 2008 to that in 2010?
Offer a very short reply. 1.29. What is the ratio of the Revenue generated (in %) of Taxes on income in 2008 to that in 2010?
Your response must be concise. 1.08. What is the ratio of the Revenue generated (in %) of Taxes on international trade in 2008 to that in 2010?
Ensure brevity in your answer.  0.9. What is the ratio of the Revenue generated (in %) of Taxes on goods and services in 2008 to that in 2011?
Your response must be concise. 1.11. What is the ratio of the Revenue generated (in %) of Taxes on income in 2008 to that in 2011?
Give a very brief answer. 1.29. What is the ratio of the Revenue generated (in %) in Taxes on international trade in 2008 to that in 2011?
Ensure brevity in your answer.  0.86. What is the ratio of the Revenue generated (in %) of Taxes on goods and services in 2008 to that in 2012?
Offer a terse response. 0.99. What is the ratio of the Revenue generated (in %) of Taxes on income in 2008 to that in 2012?
Your answer should be compact. 1.22. What is the ratio of the Revenue generated (in %) in Taxes on international trade in 2008 to that in 2012?
Make the answer very short. 0.89. What is the ratio of the Revenue generated (in %) in Taxes on goods and services in 2009 to that in 2010?
Provide a short and direct response. 1.3. What is the ratio of the Revenue generated (in %) of Taxes on income in 2009 to that in 2010?
Give a very brief answer. 1.22. What is the ratio of the Revenue generated (in %) in Taxes on international trade in 2009 to that in 2010?
Your response must be concise. 0.98. What is the ratio of the Revenue generated (in %) in Taxes on goods and services in 2009 to that in 2011?
Make the answer very short. 1.12. What is the ratio of the Revenue generated (in %) in Taxes on income in 2009 to that in 2011?
Your answer should be very brief. 1.46. What is the ratio of the Revenue generated (in %) in Taxes on international trade in 2009 to that in 2011?
Offer a very short reply. 0.94. What is the ratio of the Revenue generated (in %) in Taxes on goods and services in 2009 to that in 2012?
Provide a short and direct response. 1. What is the ratio of the Revenue generated (in %) of Taxes on income in 2009 to that in 2012?
Your answer should be compact. 1.38. What is the ratio of the Revenue generated (in %) of Taxes on international trade in 2009 to that in 2012?
Offer a very short reply. 0.98. What is the ratio of the Revenue generated (in %) in Taxes on goods and services in 2010 to that in 2011?
Ensure brevity in your answer.  0.86. What is the ratio of the Revenue generated (in %) in Taxes on income in 2010 to that in 2011?
Offer a terse response. 1.2. What is the ratio of the Revenue generated (in %) in Taxes on international trade in 2010 to that in 2011?
Make the answer very short. 0.95. What is the ratio of the Revenue generated (in %) in Taxes on goods and services in 2010 to that in 2012?
Your response must be concise. 0.76. What is the ratio of the Revenue generated (in %) in Taxes on income in 2010 to that in 2012?
Keep it short and to the point. 1.13. What is the ratio of the Revenue generated (in %) of Taxes on international trade in 2010 to that in 2012?
Your response must be concise. 0.99. What is the ratio of the Revenue generated (in %) in Taxes on goods and services in 2011 to that in 2012?
Offer a terse response. 0.89. What is the ratio of the Revenue generated (in %) in Taxes on income in 2011 to that in 2012?
Ensure brevity in your answer.  0.94. What is the ratio of the Revenue generated (in %) of Taxes on international trade in 2011 to that in 2012?
Give a very brief answer. 1.04. What is the difference between the highest and the second highest Revenue generated (in %) of Taxes on goods and services?
Your answer should be very brief. 0.2. What is the difference between the highest and the second highest Revenue generated (in %) in Taxes on income?
Offer a terse response. 0. What is the difference between the highest and the second highest Revenue generated (in %) of Taxes on international trade?
Your response must be concise. 7.71. What is the difference between the highest and the lowest Revenue generated (in %) of Taxes on goods and services?
Keep it short and to the point. 33.13. What is the difference between the highest and the lowest Revenue generated (in %) of Taxes on income?
Your response must be concise. 10.44. What is the difference between the highest and the lowest Revenue generated (in %) of Taxes on international trade?
Your response must be concise. 21.54. 